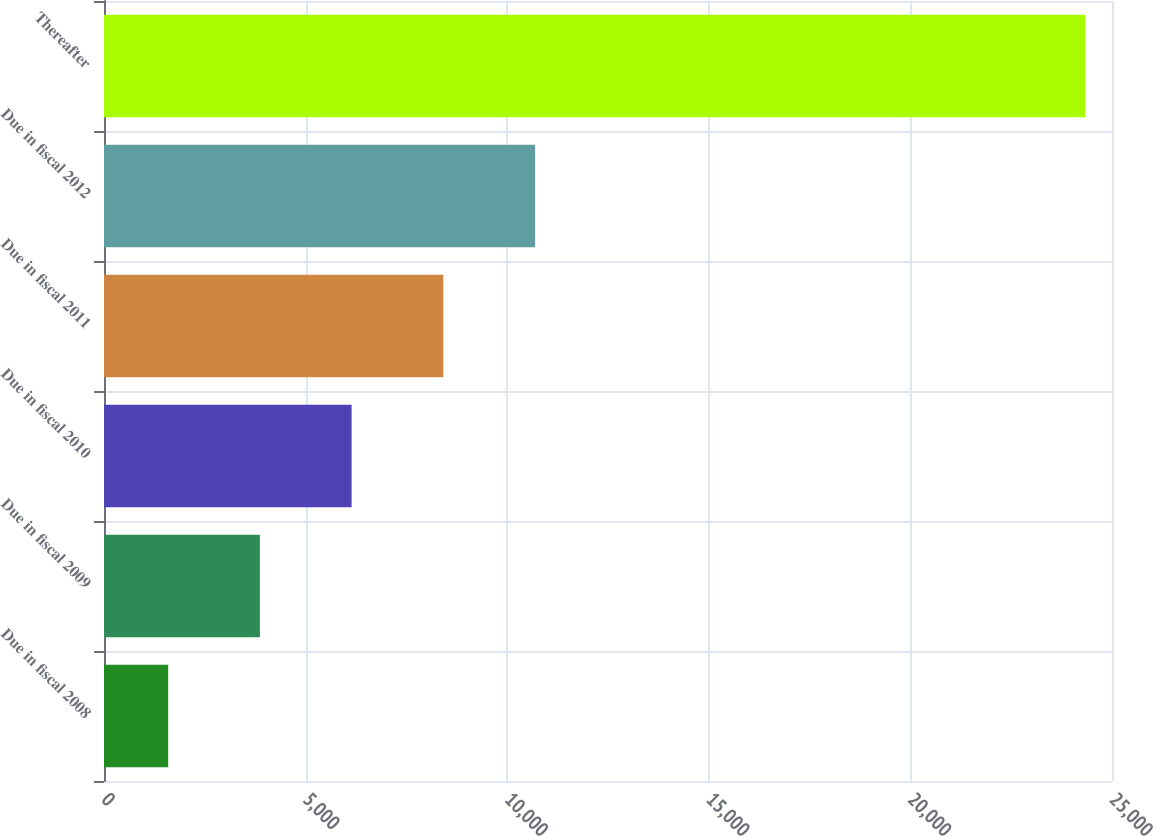Convert chart to OTSL. <chart><loc_0><loc_0><loc_500><loc_500><bar_chart><fcel>Due in fiscal 2008<fcel>Due in fiscal 2009<fcel>Due in fiscal 2010<fcel>Due in fiscal 2011<fcel>Due in fiscal 2012<fcel>Thereafter<nl><fcel>1592<fcel>3866.5<fcel>6141<fcel>8415.5<fcel>10690<fcel>24337<nl></chart> 